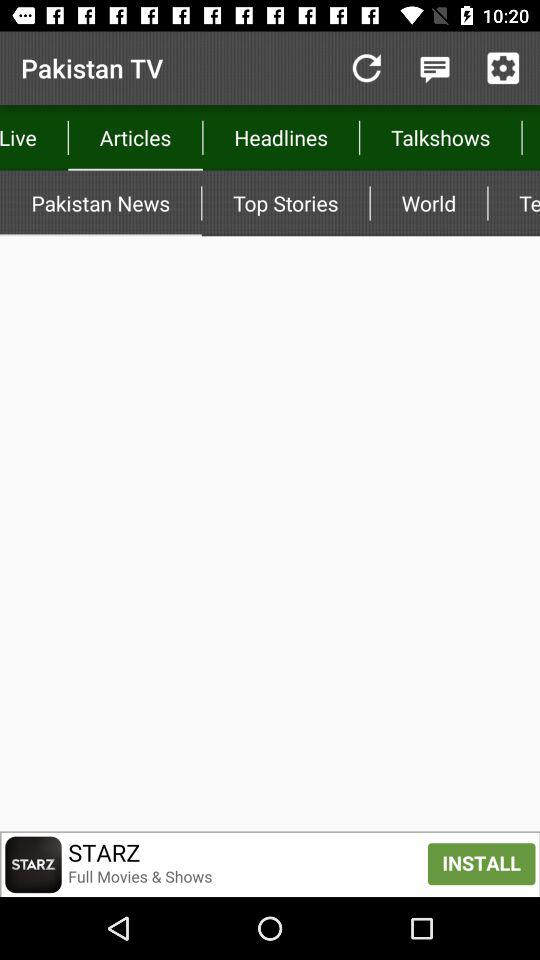What is the application name? The application name is "Pakistan TV". 